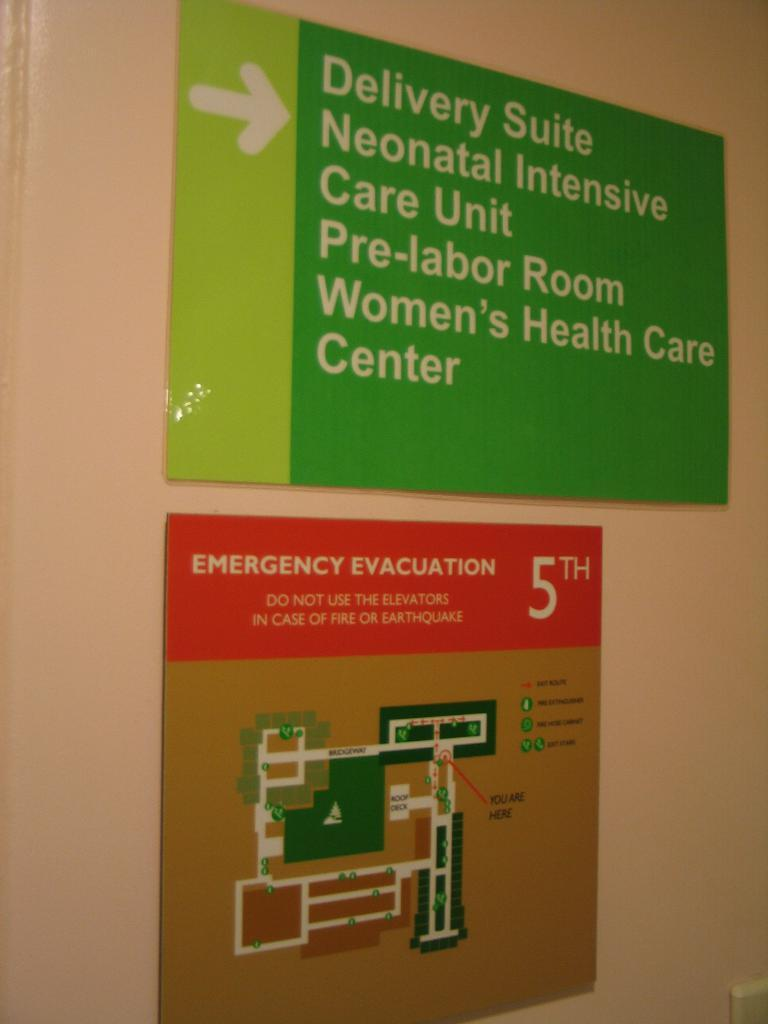What is present on the wall in the image? The wall has boards on it. Can you describe the object in the image? Unfortunately, the provided facts do not give enough information to describe the object in the image. How does the watch on the wall keep track of the debt in the image? There is no watch or debt mentioned in the image; the wall has boards on it, and there is an unspecified object present. 